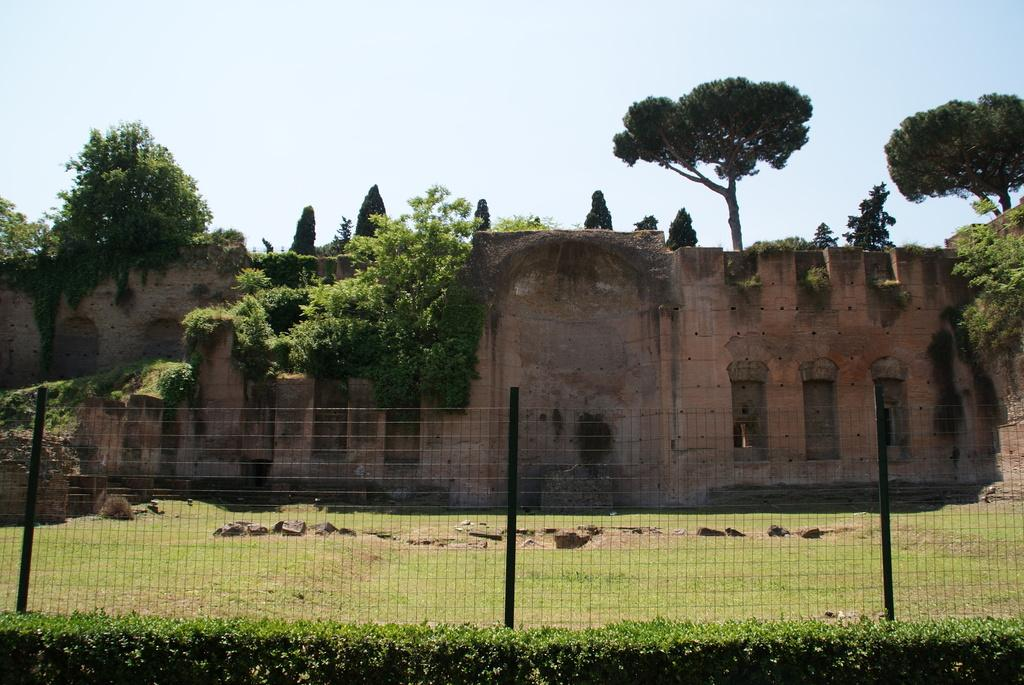What type of barrier can be seen in the image? There is a fence in the image. What type of vegetation is present in the image? There are plants and trees visible in the image. What type of ground cover is visible in the image? Grass is visible in the image. What type of structure can be seen in the image? There is a wall in the image. What is visible in the backdrop of the image? Trees are present in the backdrop of the image. What is the condition of the sky in the image? The sky is clear in the image. Can you tell me how many servants are visible in the image? There are no servants present in the image. What type of twig is being used as a prop in the image? There is no twig present in the image. 